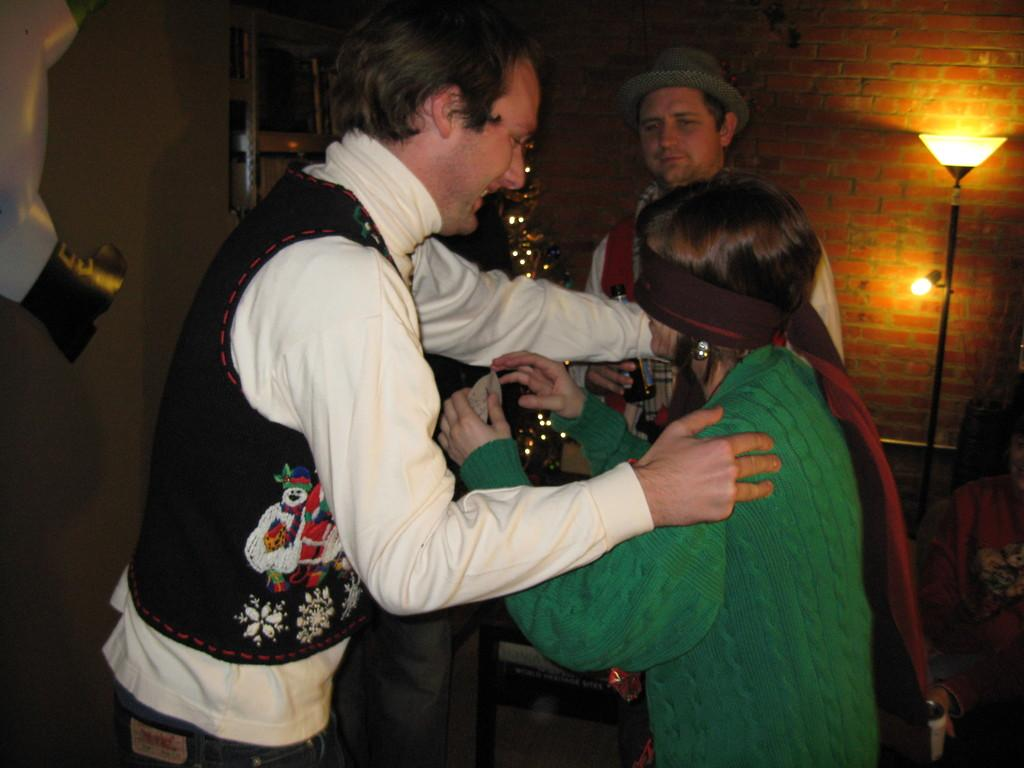How many people are present in the image? There are three people standing in the image. Where are the people standing? The people are standing on the floor. What can be seen in the background of the image? There are lights, a person, a brick wall, and other objects visible in the background of the image. What type of wine is being served at the event in the image? There is no event or wine present in the image; it features three people standing on the floor with a background that includes lights, a person, a brick wall, and other objects. 